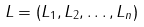Convert formula to latex. <formula><loc_0><loc_0><loc_500><loc_500>L = ( L _ { 1 } , L _ { 2 } , \dots , L _ { n } )</formula> 